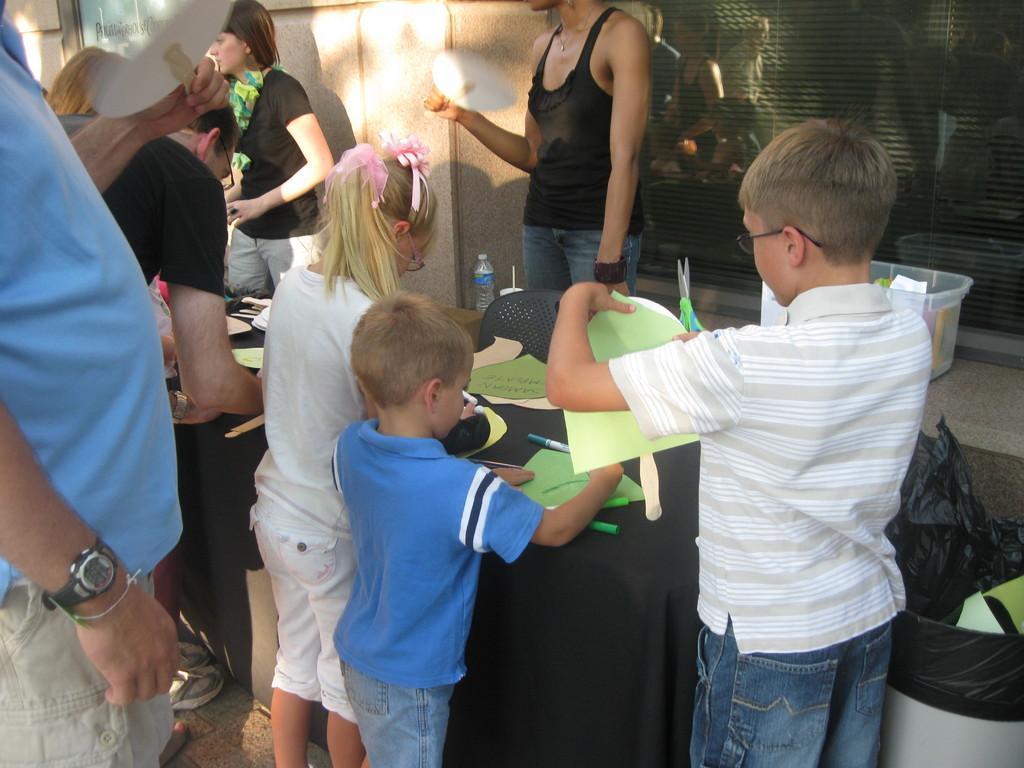Please provide a concise description of this image. In the center of the image we can see children at the table. On the table there are papers and pen. On the left side of the image there are persons standing on the floor. On the right side there is a dustbin. In the background there is a wall and container. 